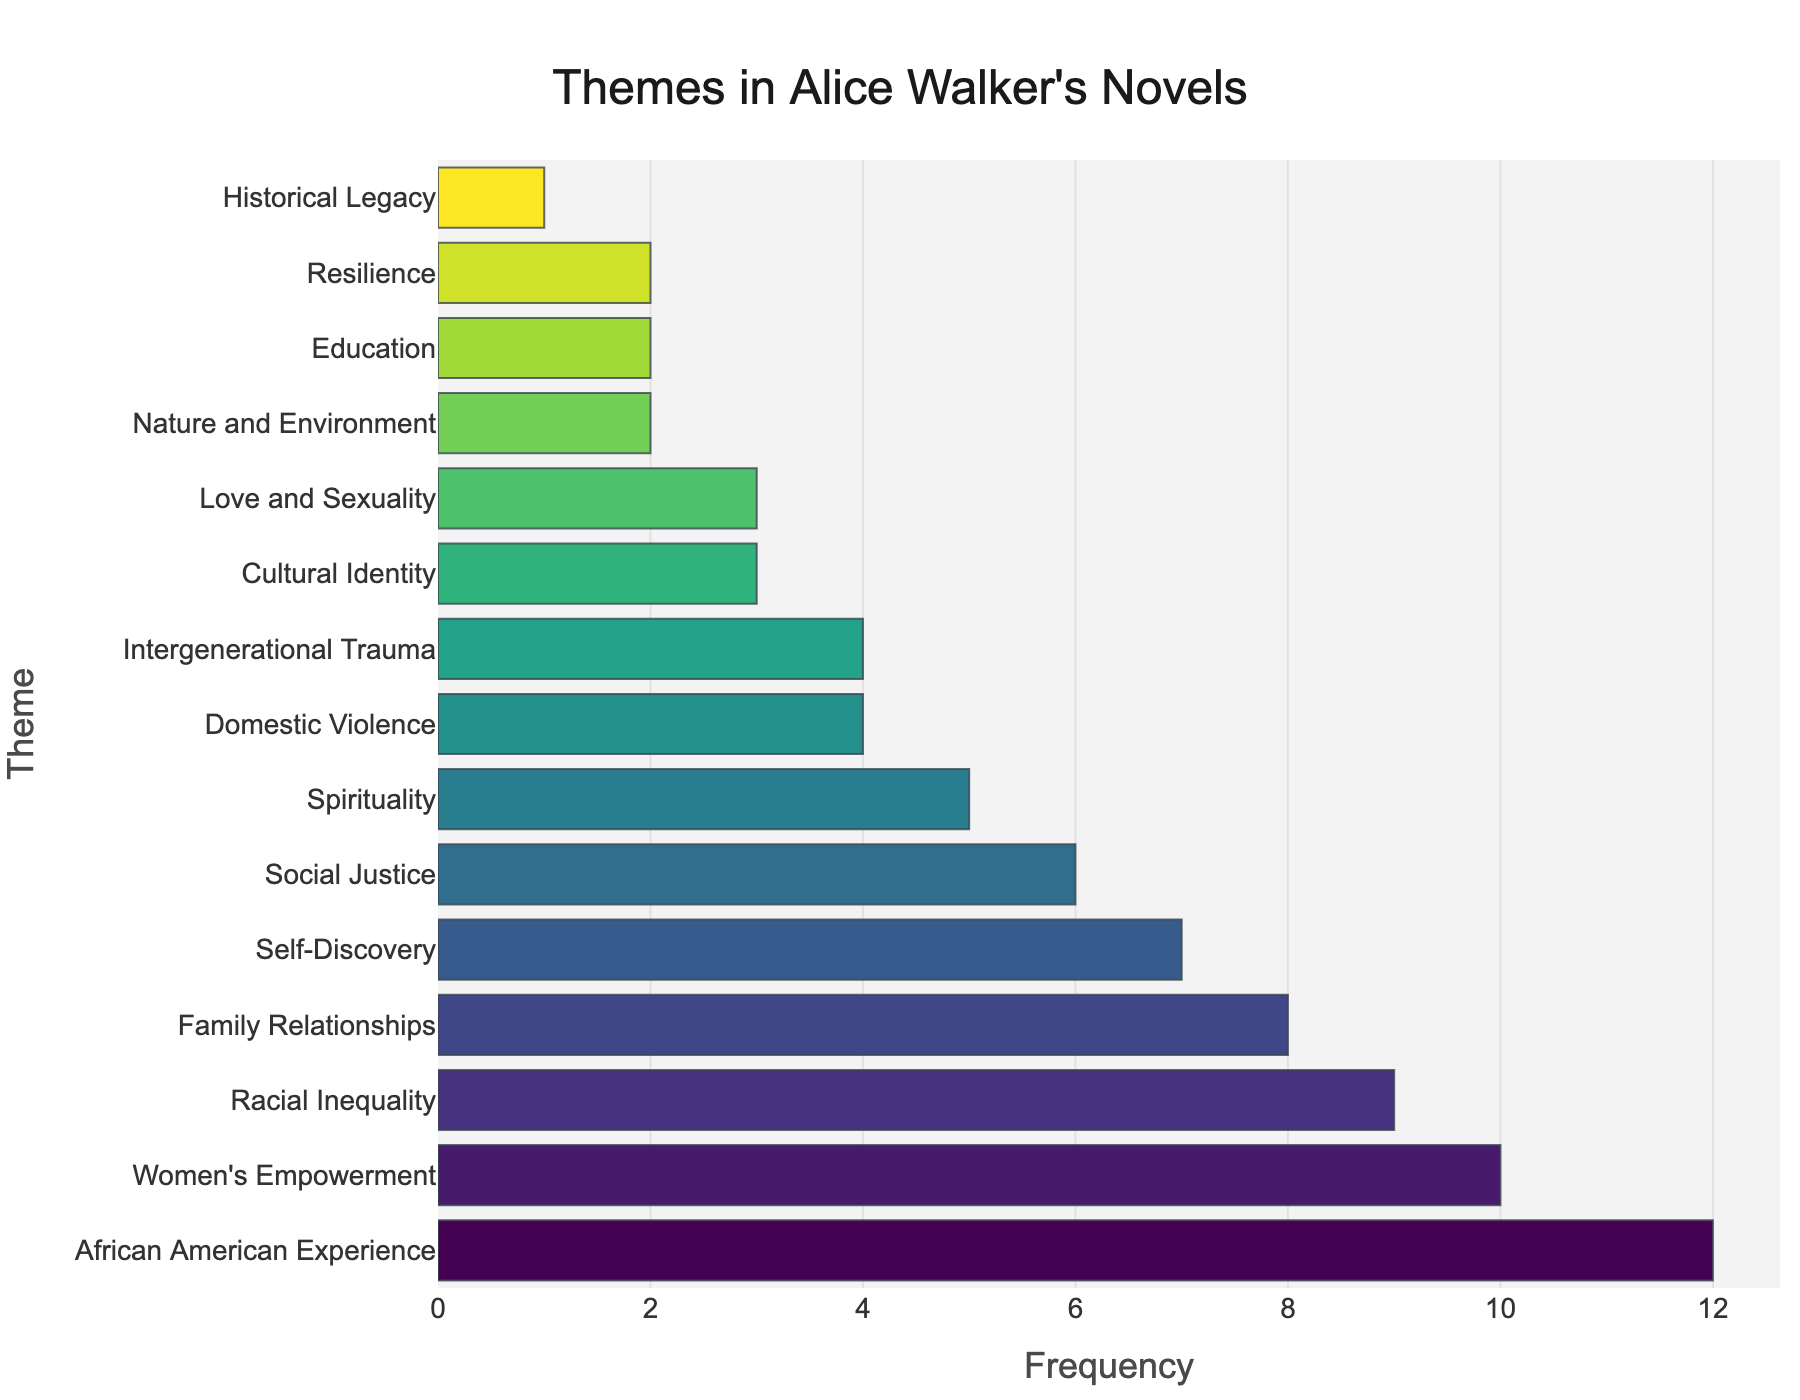What's the most frequently used theme in Alice Walker's novels? The theme with the highest bar in the chart represents the most frequently used theme. By observing the bar lengths, we see that "African American Experience" is the longest.
Answer: African American Experience Which two themes have the same frequency and are tied at 4 occurrences each? We need to look for bars that have the same length and frequency label of 4. Both "Domestic Violence" and "Intergenerational Trauma" meet this criterion.
Answer: Domestic Violence, Intergenerational Trauma How many themes have been identified a total of 10 times or more? We count the number of bars with frequencies greater than or equal to 10. Only two themes, "African American Experience" and "Women's Empowerment," fit this criteria.
Answer: 2 themes Compare the frequency of the theme "Family Relationships" with "Self-Discovery." Which one has a higher frequency and by how much? "Family Relationships" has a frequency of 8 and "Self-Discovery" has a frequency of 7. The difference is 8 - 7.
Answer: Family Relationships by 1 Calculate the total frequency for the themes that have a frequency of 2. There are three themes: "Nature and Environment," "Education," and "Resilience," each with a frequency of 2. Therefore, the sum is 2 + 2 + 2.
Answer: 6 Which theme is the least frequently mentioned, and what is its frequency? The shortest bar will represent the least frequently mentioned theme, which is "Historical Legacy" with a frequency of 1.
Answer: Historical Legacy What is the cumulative frequency of the themes related to social issues (Racial Inequality, Social Justice, Domestic Violence)? We add the frequencies of "Racial Inequality" (9), "Social Justice" (6), and "Domestic Violence" (4). Therefore, the cumulative frequency is 9 + 6 + 4.
Answer: 19 Between “Spirituality” and “Cultural Identity,” which theme appears more often, and by how much? "Spirituality" has a frequency of 5, and "Cultural Identity" has a frequency of 3. The difference is 5 - 3.
Answer: Spirituality by 2 How many themes appear only once? We count the bars with the frequency label of 1. There is only one theme, "Historical Legacy," which appears once.
Answer: 1 theme What's the average frequency of all themes? Sum the frequencies of all themes and divide by the number of themes: (12+10+9+8+7+6+5+4+4+3+3+2+2+2+1)/15. The sum is 78, and there are 15 themes, so the average is 78/15.
Answer: 5.2 